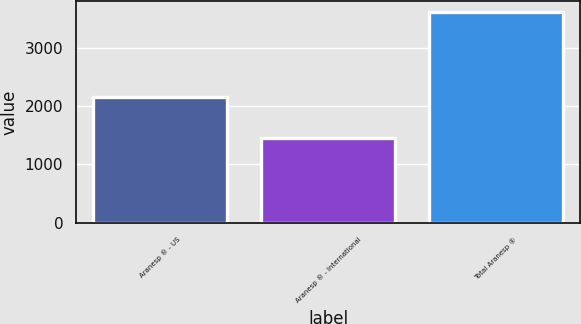Convert chart. <chart><loc_0><loc_0><loc_500><loc_500><bar_chart><fcel>Aranesp ® - US<fcel>Aranesp ® - International<fcel>Total Aranesp ®<nl><fcel>2154<fcel>1460<fcel>3614<nl></chart> 